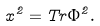Convert formula to latex. <formula><loc_0><loc_0><loc_500><loc_500>x ^ { 2 } = T r \Phi ^ { 2 } .</formula> 